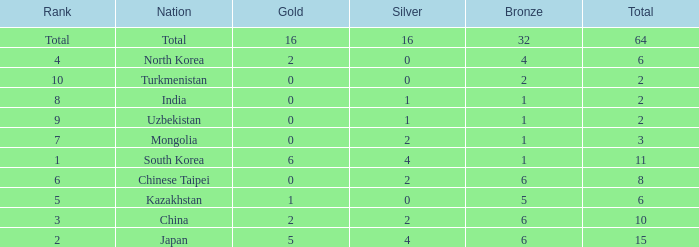What is the total Gold's less than 0? 0.0. 